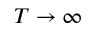Convert formula to latex. <formula><loc_0><loc_0><loc_500><loc_500>T \to \infty</formula> 